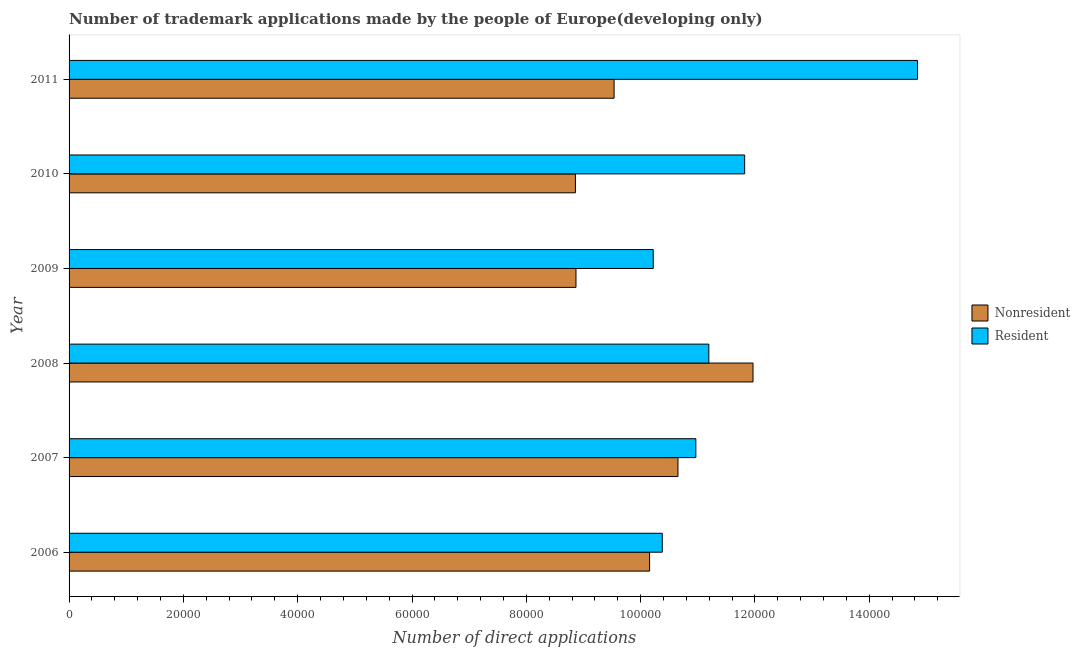How many groups of bars are there?
Your answer should be very brief. 6. Are the number of bars on each tick of the Y-axis equal?
Offer a terse response. Yes. How many bars are there on the 1st tick from the bottom?
Offer a terse response. 2. In how many cases, is the number of bars for a given year not equal to the number of legend labels?
Your answer should be compact. 0. What is the number of trademark applications made by residents in 2007?
Your answer should be very brief. 1.10e+05. Across all years, what is the maximum number of trademark applications made by residents?
Offer a terse response. 1.48e+05. Across all years, what is the minimum number of trademark applications made by residents?
Your response must be concise. 1.02e+05. In which year was the number of trademark applications made by non residents maximum?
Your answer should be very brief. 2008. What is the total number of trademark applications made by residents in the graph?
Ensure brevity in your answer.  6.94e+05. What is the difference between the number of trademark applications made by residents in 2006 and that in 2007?
Offer a very short reply. -5875. What is the difference between the number of trademark applications made by non residents in 2008 and the number of trademark applications made by residents in 2007?
Offer a very short reply. 1.00e+04. What is the average number of trademark applications made by non residents per year?
Keep it short and to the point. 1.00e+05. In the year 2011, what is the difference between the number of trademark applications made by residents and number of trademark applications made by non residents?
Keep it short and to the point. 5.31e+04. What is the ratio of the number of trademark applications made by non residents in 2009 to that in 2010?
Your answer should be compact. 1. Is the difference between the number of trademark applications made by residents in 2009 and 2010 greater than the difference between the number of trademark applications made by non residents in 2009 and 2010?
Provide a succinct answer. No. What is the difference between the highest and the second highest number of trademark applications made by non residents?
Ensure brevity in your answer.  1.31e+04. What is the difference between the highest and the lowest number of trademark applications made by non residents?
Make the answer very short. 3.11e+04. In how many years, is the number of trademark applications made by non residents greater than the average number of trademark applications made by non residents taken over all years?
Give a very brief answer. 3. Is the sum of the number of trademark applications made by non residents in 2006 and 2009 greater than the maximum number of trademark applications made by residents across all years?
Give a very brief answer. Yes. What does the 2nd bar from the top in 2009 represents?
Give a very brief answer. Nonresident. What does the 1st bar from the bottom in 2008 represents?
Your response must be concise. Nonresident. How many bars are there?
Give a very brief answer. 12. What is the difference between two consecutive major ticks on the X-axis?
Give a very brief answer. 2.00e+04. Are the values on the major ticks of X-axis written in scientific E-notation?
Give a very brief answer. No. Does the graph contain any zero values?
Your answer should be compact. No. Does the graph contain grids?
Provide a succinct answer. No. How many legend labels are there?
Your response must be concise. 2. What is the title of the graph?
Ensure brevity in your answer.  Number of trademark applications made by the people of Europe(developing only). What is the label or title of the X-axis?
Ensure brevity in your answer.  Number of direct applications. What is the label or title of the Y-axis?
Your response must be concise. Year. What is the Number of direct applications in Nonresident in 2006?
Give a very brief answer. 1.02e+05. What is the Number of direct applications of Resident in 2006?
Provide a succinct answer. 1.04e+05. What is the Number of direct applications of Nonresident in 2007?
Provide a succinct answer. 1.07e+05. What is the Number of direct applications in Resident in 2007?
Offer a terse response. 1.10e+05. What is the Number of direct applications in Nonresident in 2008?
Offer a terse response. 1.20e+05. What is the Number of direct applications of Resident in 2008?
Your response must be concise. 1.12e+05. What is the Number of direct applications of Nonresident in 2009?
Make the answer very short. 8.87e+04. What is the Number of direct applications in Resident in 2009?
Your answer should be compact. 1.02e+05. What is the Number of direct applications in Nonresident in 2010?
Offer a very short reply. 8.86e+04. What is the Number of direct applications of Resident in 2010?
Provide a succinct answer. 1.18e+05. What is the Number of direct applications of Nonresident in 2011?
Ensure brevity in your answer.  9.54e+04. What is the Number of direct applications in Resident in 2011?
Provide a short and direct response. 1.48e+05. Across all years, what is the maximum Number of direct applications of Nonresident?
Make the answer very short. 1.20e+05. Across all years, what is the maximum Number of direct applications of Resident?
Provide a succinct answer. 1.48e+05. Across all years, what is the minimum Number of direct applications in Nonresident?
Offer a very short reply. 8.86e+04. Across all years, what is the minimum Number of direct applications in Resident?
Your answer should be very brief. 1.02e+05. What is the total Number of direct applications of Nonresident in the graph?
Offer a terse response. 6.00e+05. What is the total Number of direct applications in Resident in the graph?
Ensure brevity in your answer.  6.94e+05. What is the difference between the Number of direct applications of Nonresident in 2006 and that in 2007?
Your response must be concise. -4964. What is the difference between the Number of direct applications of Resident in 2006 and that in 2007?
Make the answer very short. -5875. What is the difference between the Number of direct applications of Nonresident in 2006 and that in 2008?
Provide a succinct answer. -1.81e+04. What is the difference between the Number of direct applications of Resident in 2006 and that in 2008?
Provide a succinct answer. -8147. What is the difference between the Number of direct applications of Nonresident in 2006 and that in 2009?
Provide a succinct answer. 1.29e+04. What is the difference between the Number of direct applications of Resident in 2006 and that in 2009?
Keep it short and to the point. 1580. What is the difference between the Number of direct applications in Nonresident in 2006 and that in 2010?
Ensure brevity in your answer.  1.30e+04. What is the difference between the Number of direct applications in Resident in 2006 and that in 2010?
Give a very brief answer. -1.44e+04. What is the difference between the Number of direct applications of Nonresident in 2006 and that in 2011?
Offer a very short reply. 6212. What is the difference between the Number of direct applications of Resident in 2006 and that in 2011?
Give a very brief answer. -4.47e+04. What is the difference between the Number of direct applications in Nonresident in 2007 and that in 2008?
Offer a very short reply. -1.31e+04. What is the difference between the Number of direct applications in Resident in 2007 and that in 2008?
Your answer should be very brief. -2272. What is the difference between the Number of direct applications in Nonresident in 2007 and that in 2009?
Your answer should be compact. 1.78e+04. What is the difference between the Number of direct applications of Resident in 2007 and that in 2009?
Offer a terse response. 7455. What is the difference between the Number of direct applications in Nonresident in 2007 and that in 2010?
Your answer should be compact. 1.79e+04. What is the difference between the Number of direct applications of Resident in 2007 and that in 2010?
Your answer should be very brief. -8542. What is the difference between the Number of direct applications in Nonresident in 2007 and that in 2011?
Offer a very short reply. 1.12e+04. What is the difference between the Number of direct applications in Resident in 2007 and that in 2011?
Provide a short and direct response. -3.88e+04. What is the difference between the Number of direct applications of Nonresident in 2008 and that in 2009?
Give a very brief answer. 3.10e+04. What is the difference between the Number of direct applications of Resident in 2008 and that in 2009?
Your response must be concise. 9727. What is the difference between the Number of direct applications of Nonresident in 2008 and that in 2010?
Make the answer very short. 3.11e+04. What is the difference between the Number of direct applications of Resident in 2008 and that in 2010?
Your answer should be compact. -6270. What is the difference between the Number of direct applications of Nonresident in 2008 and that in 2011?
Provide a short and direct response. 2.43e+04. What is the difference between the Number of direct applications in Resident in 2008 and that in 2011?
Give a very brief answer. -3.65e+04. What is the difference between the Number of direct applications in Resident in 2009 and that in 2010?
Give a very brief answer. -1.60e+04. What is the difference between the Number of direct applications of Nonresident in 2009 and that in 2011?
Your answer should be very brief. -6667. What is the difference between the Number of direct applications of Resident in 2009 and that in 2011?
Ensure brevity in your answer.  -4.62e+04. What is the difference between the Number of direct applications of Nonresident in 2010 and that in 2011?
Provide a succinct answer. -6767. What is the difference between the Number of direct applications in Resident in 2010 and that in 2011?
Make the answer very short. -3.02e+04. What is the difference between the Number of direct applications in Nonresident in 2006 and the Number of direct applications in Resident in 2007?
Keep it short and to the point. -8091. What is the difference between the Number of direct applications in Nonresident in 2006 and the Number of direct applications in Resident in 2008?
Offer a very short reply. -1.04e+04. What is the difference between the Number of direct applications in Nonresident in 2006 and the Number of direct applications in Resident in 2009?
Your answer should be compact. -636. What is the difference between the Number of direct applications in Nonresident in 2006 and the Number of direct applications in Resident in 2010?
Make the answer very short. -1.66e+04. What is the difference between the Number of direct applications of Nonresident in 2006 and the Number of direct applications of Resident in 2011?
Give a very brief answer. -4.69e+04. What is the difference between the Number of direct applications of Nonresident in 2007 and the Number of direct applications of Resident in 2008?
Ensure brevity in your answer.  -5399. What is the difference between the Number of direct applications in Nonresident in 2007 and the Number of direct applications in Resident in 2009?
Offer a terse response. 4328. What is the difference between the Number of direct applications in Nonresident in 2007 and the Number of direct applications in Resident in 2010?
Your answer should be compact. -1.17e+04. What is the difference between the Number of direct applications of Nonresident in 2007 and the Number of direct applications of Resident in 2011?
Offer a terse response. -4.19e+04. What is the difference between the Number of direct applications of Nonresident in 2008 and the Number of direct applications of Resident in 2009?
Your answer should be compact. 1.75e+04. What is the difference between the Number of direct applications of Nonresident in 2008 and the Number of direct applications of Resident in 2010?
Your response must be concise. 1462. What is the difference between the Number of direct applications of Nonresident in 2008 and the Number of direct applications of Resident in 2011?
Your answer should be very brief. -2.88e+04. What is the difference between the Number of direct applications of Nonresident in 2009 and the Number of direct applications of Resident in 2010?
Offer a terse response. -2.95e+04. What is the difference between the Number of direct applications in Nonresident in 2009 and the Number of direct applications in Resident in 2011?
Keep it short and to the point. -5.98e+04. What is the difference between the Number of direct applications in Nonresident in 2010 and the Number of direct applications in Resident in 2011?
Keep it short and to the point. -5.99e+04. What is the average Number of direct applications of Nonresident per year?
Your response must be concise. 1.00e+05. What is the average Number of direct applications in Resident per year?
Provide a short and direct response. 1.16e+05. In the year 2006, what is the difference between the Number of direct applications in Nonresident and Number of direct applications in Resident?
Provide a short and direct response. -2216. In the year 2007, what is the difference between the Number of direct applications in Nonresident and Number of direct applications in Resident?
Give a very brief answer. -3127. In the year 2008, what is the difference between the Number of direct applications of Nonresident and Number of direct applications of Resident?
Your answer should be very brief. 7732. In the year 2009, what is the difference between the Number of direct applications in Nonresident and Number of direct applications in Resident?
Your answer should be compact. -1.35e+04. In the year 2010, what is the difference between the Number of direct applications of Nonresident and Number of direct applications of Resident?
Your answer should be very brief. -2.96e+04. In the year 2011, what is the difference between the Number of direct applications of Nonresident and Number of direct applications of Resident?
Provide a succinct answer. -5.31e+04. What is the ratio of the Number of direct applications of Nonresident in 2006 to that in 2007?
Keep it short and to the point. 0.95. What is the ratio of the Number of direct applications of Resident in 2006 to that in 2007?
Give a very brief answer. 0.95. What is the ratio of the Number of direct applications of Nonresident in 2006 to that in 2008?
Your answer should be compact. 0.85. What is the ratio of the Number of direct applications in Resident in 2006 to that in 2008?
Offer a terse response. 0.93. What is the ratio of the Number of direct applications in Nonresident in 2006 to that in 2009?
Your answer should be very brief. 1.15. What is the ratio of the Number of direct applications of Resident in 2006 to that in 2009?
Provide a short and direct response. 1.02. What is the ratio of the Number of direct applications in Nonresident in 2006 to that in 2010?
Provide a short and direct response. 1.15. What is the ratio of the Number of direct applications in Resident in 2006 to that in 2010?
Offer a very short reply. 0.88. What is the ratio of the Number of direct applications in Nonresident in 2006 to that in 2011?
Keep it short and to the point. 1.07. What is the ratio of the Number of direct applications of Resident in 2006 to that in 2011?
Your answer should be compact. 0.7. What is the ratio of the Number of direct applications in Nonresident in 2007 to that in 2008?
Your answer should be compact. 0.89. What is the ratio of the Number of direct applications of Resident in 2007 to that in 2008?
Offer a very short reply. 0.98. What is the ratio of the Number of direct applications in Nonresident in 2007 to that in 2009?
Ensure brevity in your answer.  1.2. What is the ratio of the Number of direct applications of Resident in 2007 to that in 2009?
Make the answer very short. 1.07. What is the ratio of the Number of direct applications in Nonresident in 2007 to that in 2010?
Offer a very short reply. 1.2. What is the ratio of the Number of direct applications in Resident in 2007 to that in 2010?
Offer a terse response. 0.93. What is the ratio of the Number of direct applications in Nonresident in 2007 to that in 2011?
Your answer should be very brief. 1.12. What is the ratio of the Number of direct applications of Resident in 2007 to that in 2011?
Ensure brevity in your answer.  0.74. What is the ratio of the Number of direct applications of Nonresident in 2008 to that in 2009?
Offer a terse response. 1.35. What is the ratio of the Number of direct applications of Resident in 2008 to that in 2009?
Keep it short and to the point. 1.1. What is the ratio of the Number of direct applications in Nonresident in 2008 to that in 2010?
Keep it short and to the point. 1.35. What is the ratio of the Number of direct applications of Resident in 2008 to that in 2010?
Give a very brief answer. 0.95. What is the ratio of the Number of direct applications of Nonresident in 2008 to that in 2011?
Your answer should be very brief. 1.25. What is the ratio of the Number of direct applications of Resident in 2008 to that in 2011?
Offer a terse response. 0.75. What is the ratio of the Number of direct applications in Resident in 2009 to that in 2010?
Make the answer very short. 0.86. What is the ratio of the Number of direct applications in Nonresident in 2009 to that in 2011?
Your answer should be very brief. 0.93. What is the ratio of the Number of direct applications of Resident in 2009 to that in 2011?
Give a very brief answer. 0.69. What is the ratio of the Number of direct applications in Nonresident in 2010 to that in 2011?
Your response must be concise. 0.93. What is the ratio of the Number of direct applications of Resident in 2010 to that in 2011?
Make the answer very short. 0.8. What is the difference between the highest and the second highest Number of direct applications in Nonresident?
Your answer should be very brief. 1.31e+04. What is the difference between the highest and the second highest Number of direct applications in Resident?
Offer a terse response. 3.02e+04. What is the difference between the highest and the lowest Number of direct applications of Nonresident?
Provide a succinct answer. 3.11e+04. What is the difference between the highest and the lowest Number of direct applications in Resident?
Offer a very short reply. 4.62e+04. 